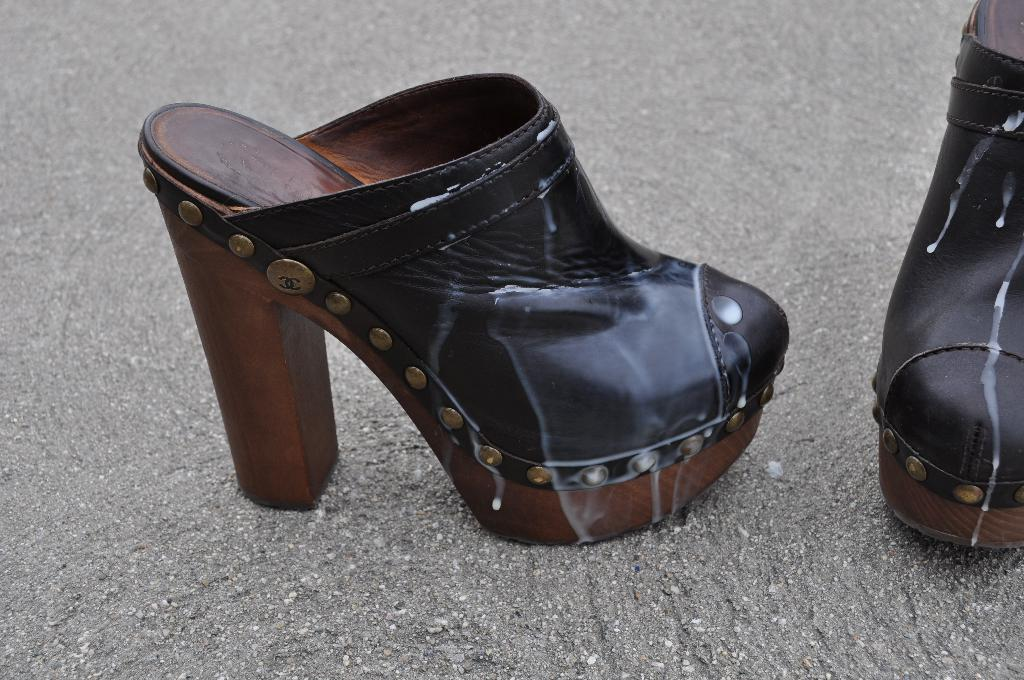What type of objects are present in the image? There are two women's footwear in the image. Where are the footwear located? The footwear is on the road. What color is the boat in the image? There is no boat present in the image. 